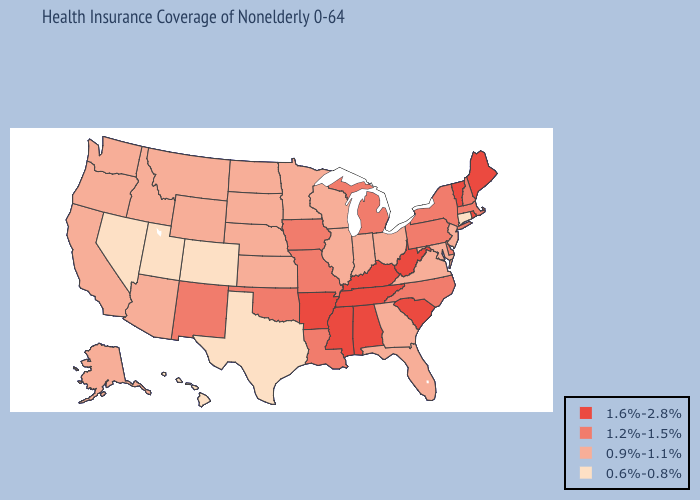What is the lowest value in states that border Virginia?
Short answer required. 0.9%-1.1%. What is the highest value in the South ?
Short answer required. 1.6%-2.8%. Which states have the highest value in the USA?
Answer briefly. Alabama, Arkansas, Kentucky, Maine, Mississippi, Rhode Island, South Carolina, Tennessee, Vermont, West Virginia. What is the highest value in states that border Kansas?
Give a very brief answer. 1.2%-1.5%. What is the highest value in states that border Nevada?
Be succinct. 0.9%-1.1%. Which states have the lowest value in the Northeast?
Concise answer only. Connecticut. Does Wyoming have the lowest value in the West?
Give a very brief answer. No. What is the value of Rhode Island?
Concise answer only. 1.6%-2.8%. What is the value of New York?
Keep it brief. 1.2%-1.5%. What is the value of Louisiana?
Write a very short answer. 1.2%-1.5%. Which states hav the highest value in the South?
Give a very brief answer. Alabama, Arkansas, Kentucky, Mississippi, South Carolina, Tennessee, West Virginia. Which states have the highest value in the USA?
Give a very brief answer. Alabama, Arkansas, Kentucky, Maine, Mississippi, Rhode Island, South Carolina, Tennessee, Vermont, West Virginia. What is the lowest value in states that border Texas?
Write a very short answer. 1.2%-1.5%. What is the value of Alaska?
Quick response, please. 0.9%-1.1%. 